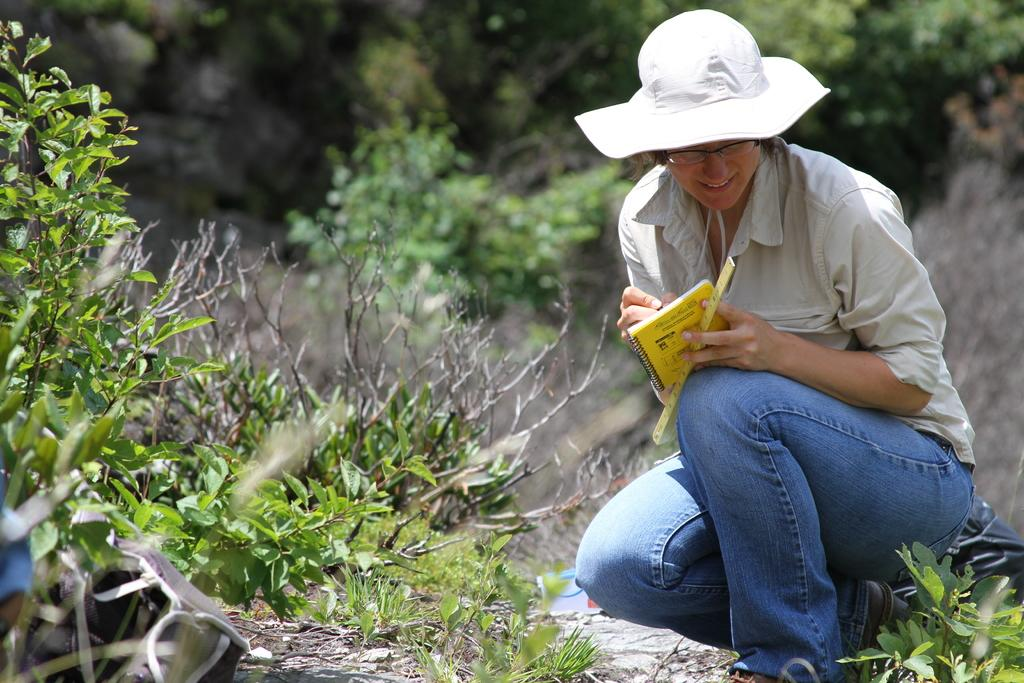What is present in the image along with the woman? There is a plant in the image. Where are the plants located in the image? There are plants on the left side of the image. How would you describe the background of the image? The background of the image is blurred. What type of environment is suggested by the background? There is greenery in the background of the image, suggesting a natural or outdoor setting. What type of animal is leading the woman in the image? There is no animal present in the image, and the woman is not being led by any creature. 